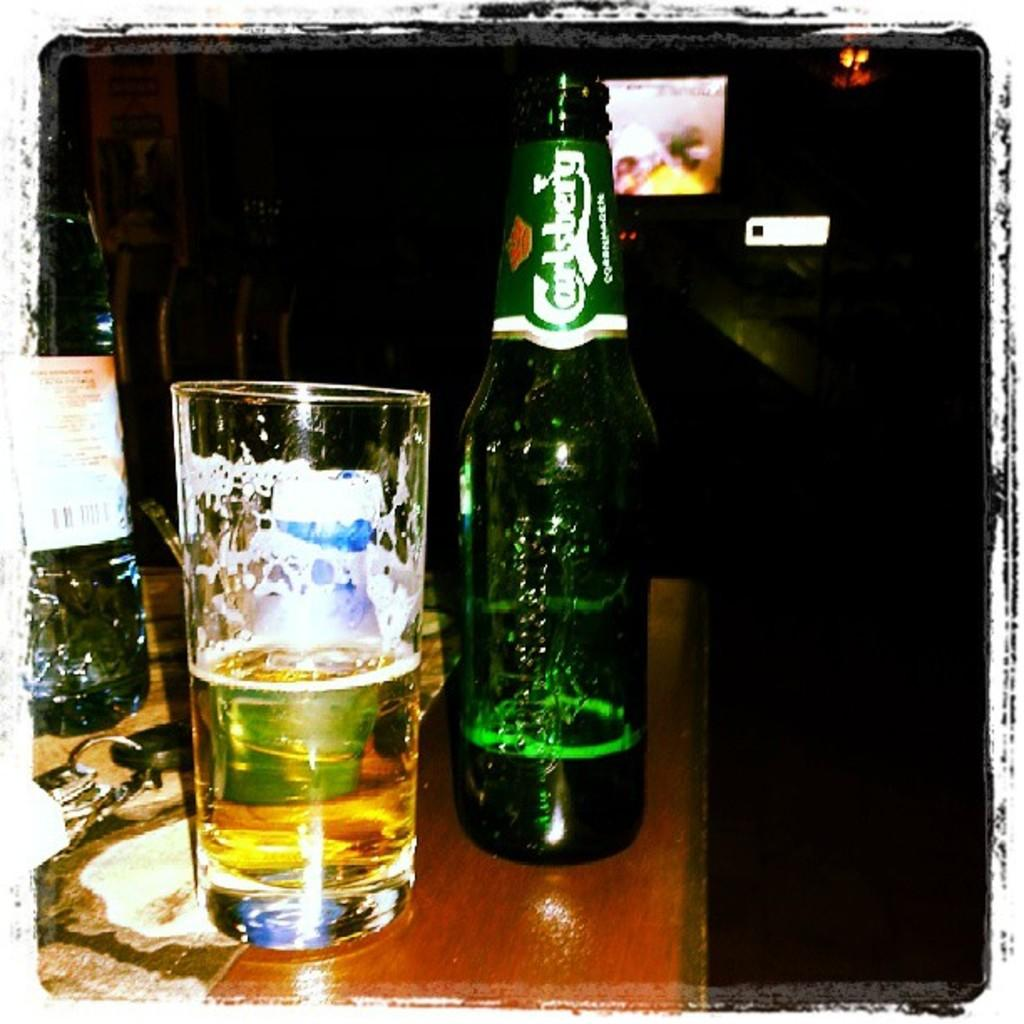Provide a one-sentence caption for the provided image. An almost empty bottle of Carlsberg sits beside a half full glass on a bar. 